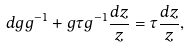Convert formula to latex. <formula><loc_0><loc_0><loc_500><loc_500>d g g ^ { - 1 } + g \tau g ^ { - 1 } \frac { d z } { z } = \tau \frac { d z } { z } ,</formula> 